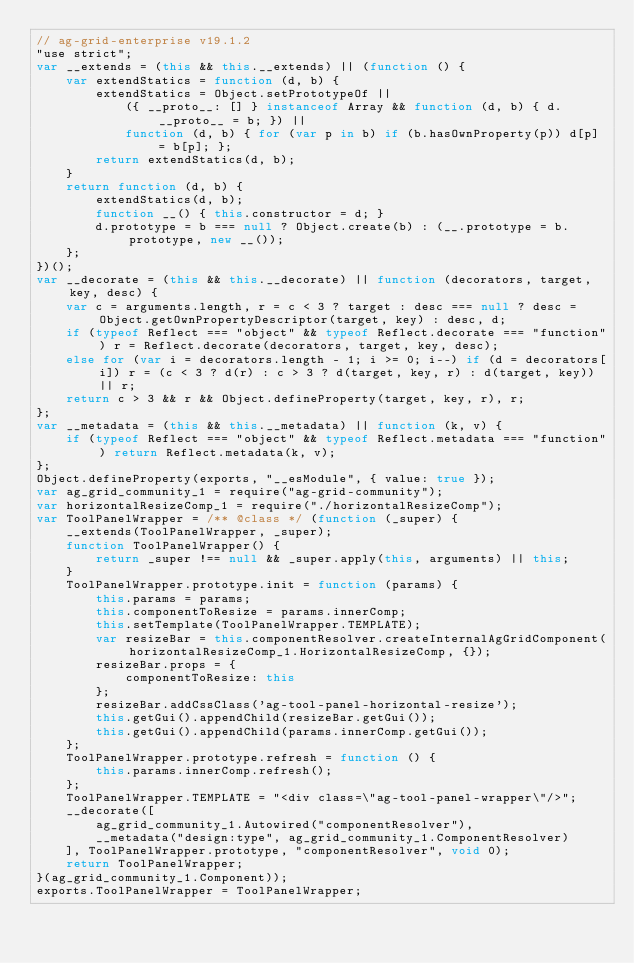Convert code to text. <code><loc_0><loc_0><loc_500><loc_500><_JavaScript_>// ag-grid-enterprise v19.1.2
"use strict";
var __extends = (this && this.__extends) || (function () {
    var extendStatics = function (d, b) {
        extendStatics = Object.setPrototypeOf ||
            ({ __proto__: [] } instanceof Array && function (d, b) { d.__proto__ = b; }) ||
            function (d, b) { for (var p in b) if (b.hasOwnProperty(p)) d[p] = b[p]; };
        return extendStatics(d, b);
    }
    return function (d, b) {
        extendStatics(d, b);
        function __() { this.constructor = d; }
        d.prototype = b === null ? Object.create(b) : (__.prototype = b.prototype, new __());
    };
})();
var __decorate = (this && this.__decorate) || function (decorators, target, key, desc) {
    var c = arguments.length, r = c < 3 ? target : desc === null ? desc = Object.getOwnPropertyDescriptor(target, key) : desc, d;
    if (typeof Reflect === "object" && typeof Reflect.decorate === "function") r = Reflect.decorate(decorators, target, key, desc);
    else for (var i = decorators.length - 1; i >= 0; i--) if (d = decorators[i]) r = (c < 3 ? d(r) : c > 3 ? d(target, key, r) : d(target, key)) || r;
    return c > 3 && r && Object.defineProperty(target, key, r), r;
};
var __metadata = (this && this.__metadata) || function (k, v) {
    if (typeof Reflect === "object" && typeof Reflect.metadata === "function") return Reflect.metadata(k, v);
};
Object.defineProperty(exports, "__esModule", { value: true });
var ag_grid_community_1 = require("ag-grid-community");
var horizontalResizeComp_1 = require("./horizontalResizeComp");
var ToolPanelWrapper = /** @class */ (function (_super) {
    __extends(ToolPanelWrapper, _super);
    function ToolPanelWrapper() {
        return _super !== null && _super.apply(this, arguments) || this;
    }
    ToolPanelWrapper.prototype.init = function (params) {
        this.params = params;
        this.componentToResize = params.innerComp;
        this.setTemplate(ToolPanelWrapper.TEMPLATE);
        var resizeBar = this.componentResolver.createInternalAgGridComponent(horizontalResizeComp_1.HorizontalResizeComp, {});
        resizeBar.props = {
            componentToResize: this
        };
        resizeBar.addCssClass('ag-tool-panel-horizontal-resize');
        this.getGui().appendChild(resizeBar.getGui());
        this.getGui().appendChild(params.innerComp.getGui());
    };
    ToolPanelWrapper.prototype.refresh = function () {
        this.params.innerComp.refresh();
    };
    ToolPanelWrapper.TEMPLATE = "<div class=\"ag-tool-panel-wrapper\"/>";
    __decorate([
        ag_grid_community_1.Autowired("componentResolver"),
        __metadata("design:type", ag_grid_community_1.ComponentResolver)
    ], ToolPanelWrapper.prototype, "componentResolver", void 0);
    return ToolPanelWrapper;
}(ag_grid_community_1.Component));
exports.ToolPanelWrapper = ToolPanelWrapper;
</code> 